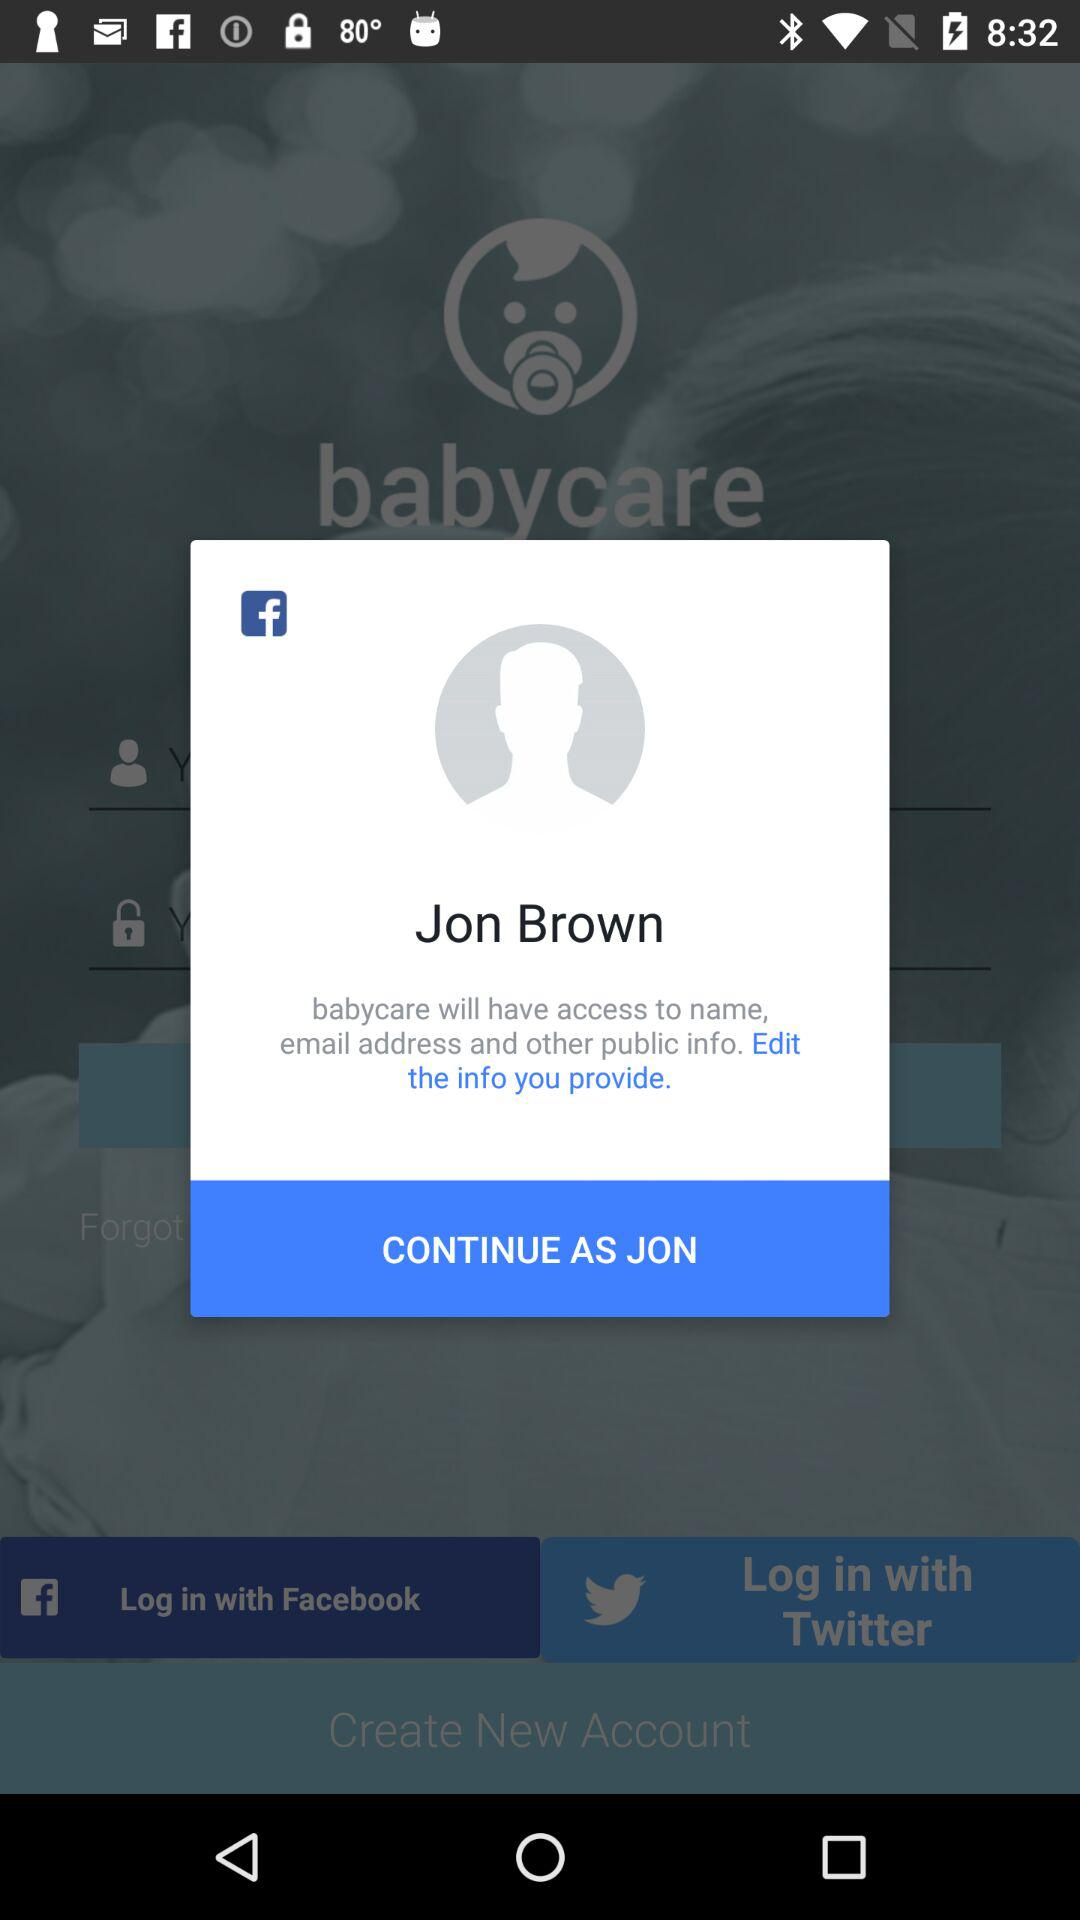How old is Jon Brown?
When the provided information is insufficient, respond with <no answer>. <no answer> 